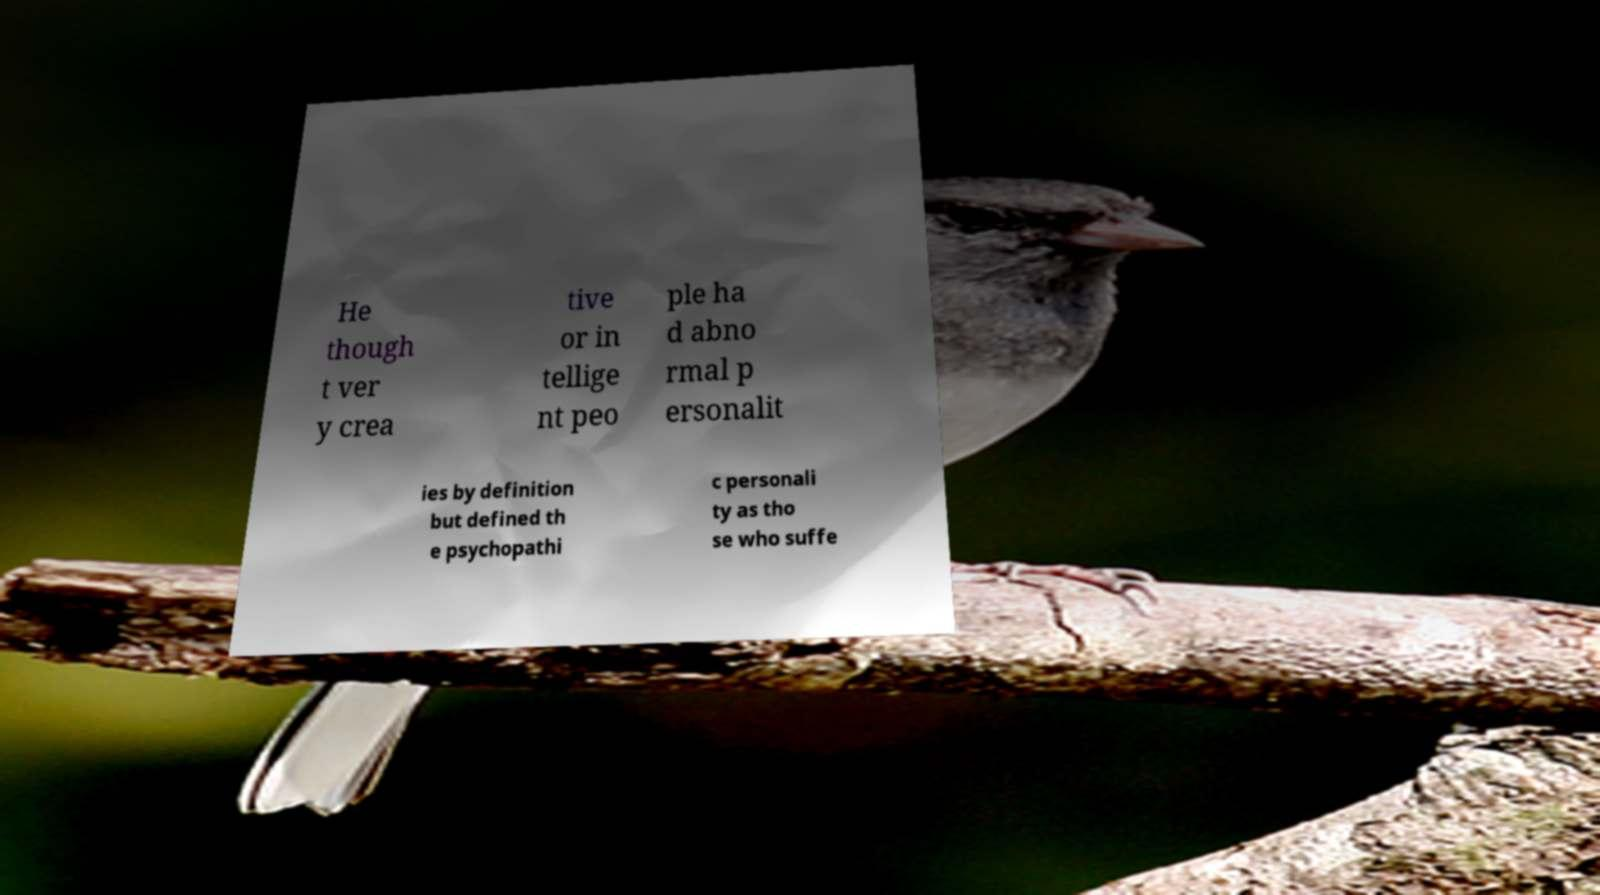I need the written content from this picture converted into text. Can you do that? He though t ver y crea tive or in tellige nt peo ple ha d abno rmal p ersonalit ies by definition but defined th e psychopathi c personali ty as tho se who suffe 